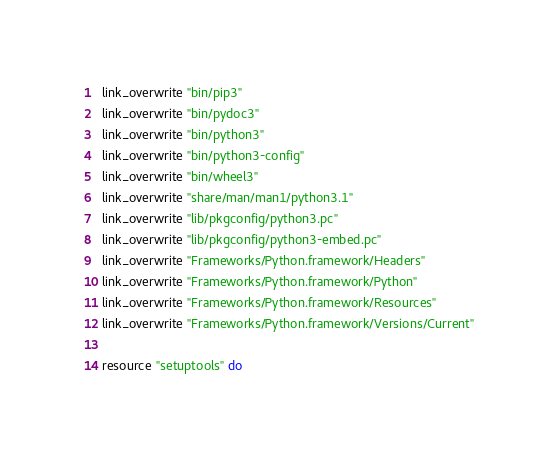Convert code to text. <code><loc_0><loc_0><loc_500><loc_500><_Ruby_>  link_overwrite "bin/pip3"
  link_overwrite "bin/pydoc3"
  link_overwrite "bin/python3"
  link_overwrite "bin/python3-config"
  link_overwrite "bin/wheel3"
  link_overwrite "share/man/man1/python3.1"
  link_overwrite "lib/pkgconfig/python3.pc"
  link_overwrite "lib/pkgconfig/python3-embed.pc"
  link_overwrite "Frameworks/Python.framework/Headers"
  link_overwrite "Frameworks/Python.framework/Python"
  link_overwrite "Frameworks/Python.framework/Resources"
  link_overwrite "Frameworks/Python.framework/Versions/Current"

  resource "setuptools" do</code> 